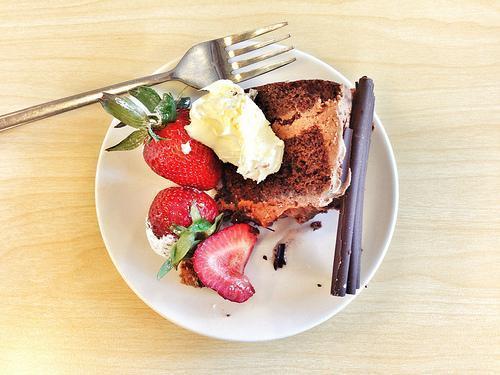How many strawberries are there?
Give a very brief answer. 3. 